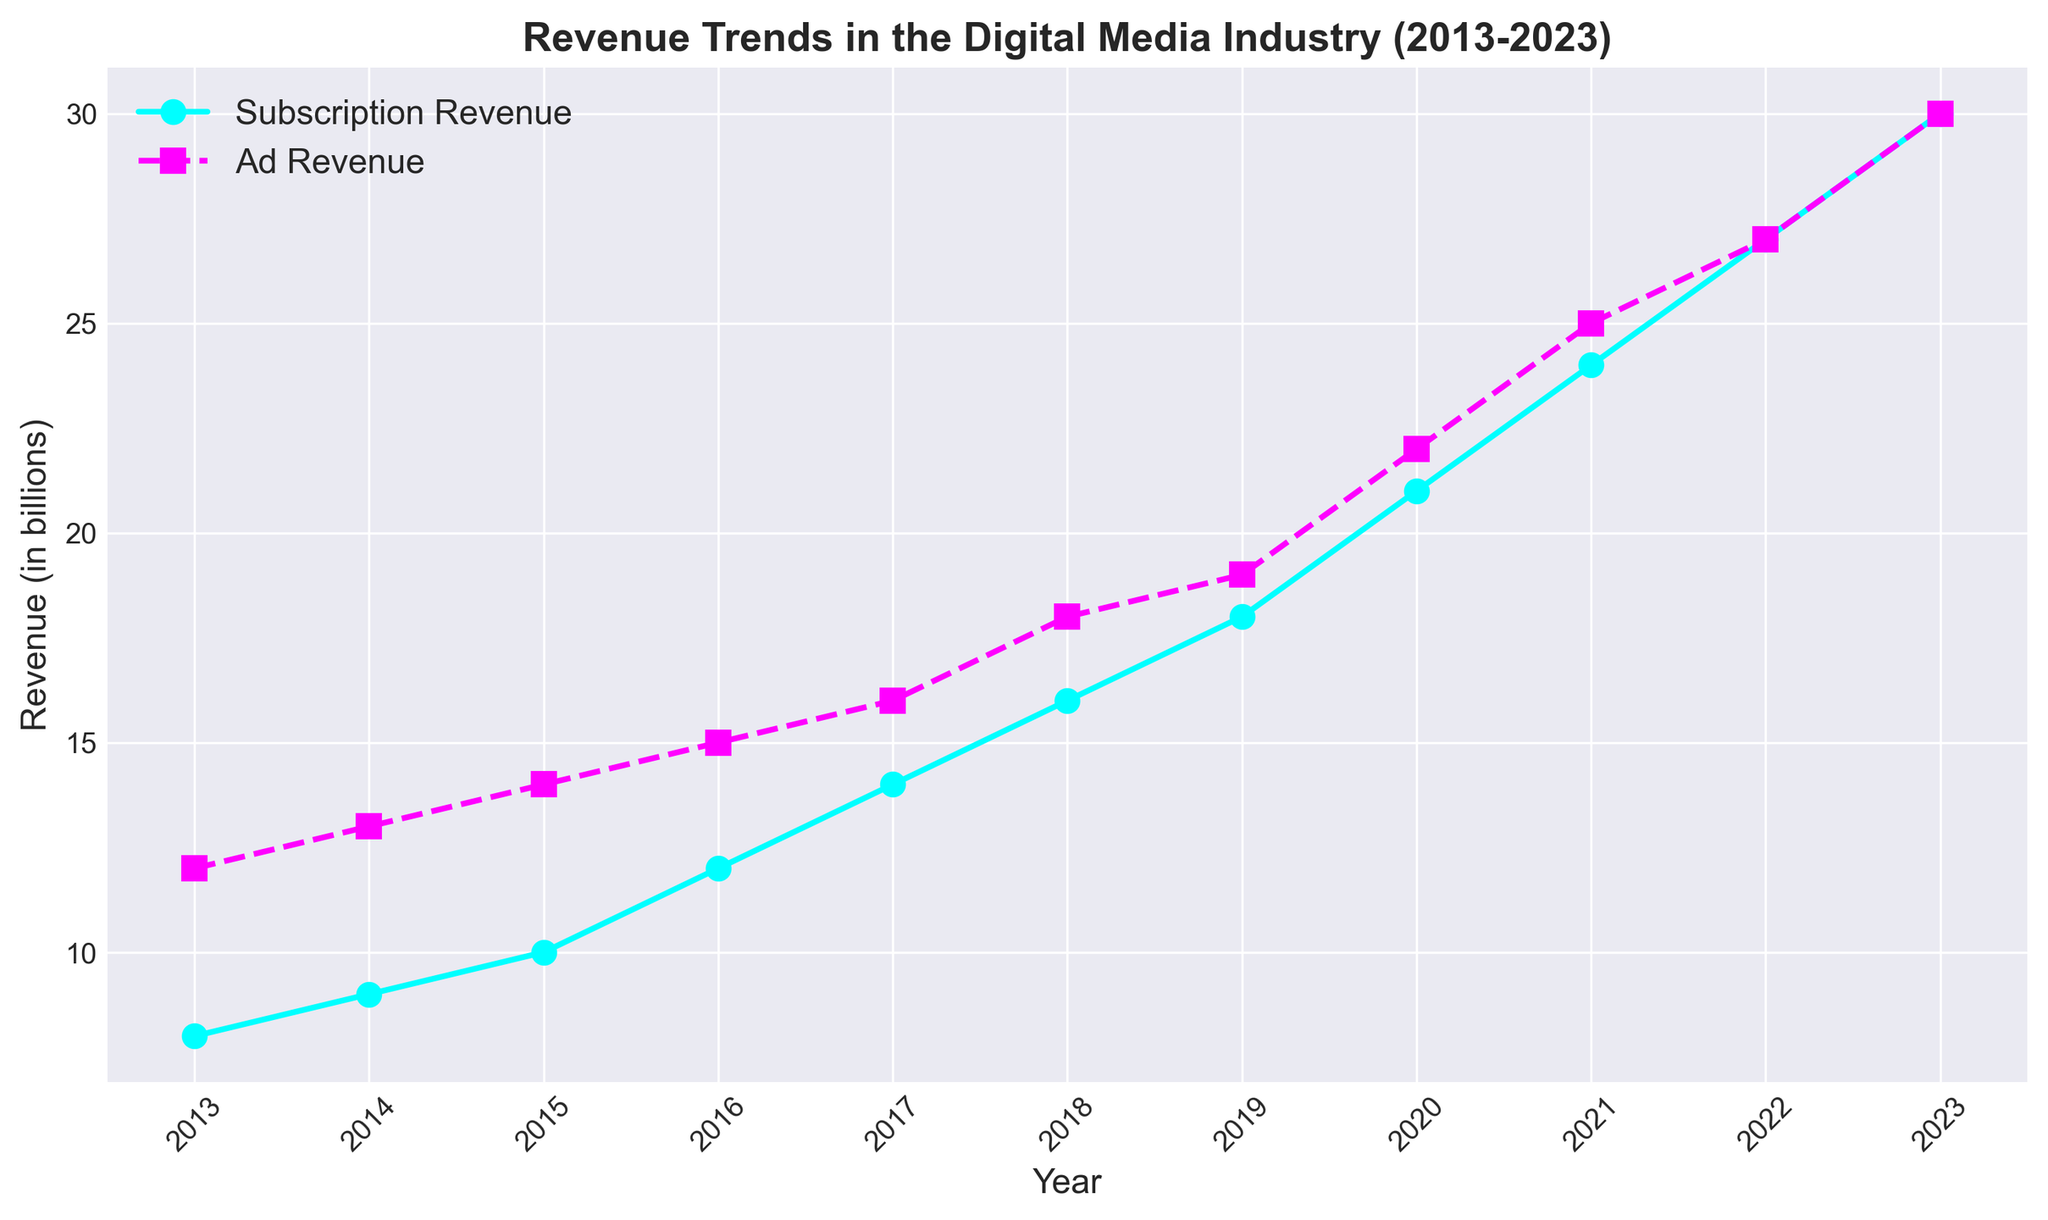What's the trend in subscription revenue from 2013 to 2023? The line representing subscription revenue shows a continuous upward trajectory from 2013 to 2023, starting at 8 billion in 2013 and reaching 30 billion in 2023.
Answer: Upward trend How does the trend in ad revenue compare to the trend in subscription revenue over the decade? Both subscription and ad revenue show an increasing trend. However, subscription revenue increases more steeply, especially from 2020 to 2023, resulting in a higher final value in 2023.
Answer: Subscription revenue increases faster Which year shows an equal revenue for both subscriptions and ads? By looking at the two lines, they intersect at 2022, where both subscription and ad revenue are 27 billion.
Answer: 2022 What is the total combined revenue (subscription + ad) in 2019? Subscription revenue in 2019 is 18 billion and ad revenue is 19 billion. The total combined revenue is 18 + 19 = 37 billion.
Answer: 37 billion In which year is the difference between subscription revenue and ad revenue the highest? By examining the gaps between the two lines, the largest difference appears in 2023, where subscription revenue is 30 billion and ad revenue is 30 billion. The difference is 30 - 30 = 0.
Answer: 2023 Compare the subscription revenue in 2018 with ad revenue in 2014. Which is higher and by how much? Subscription revenue in 2018 is 16 billion, and ad revenue in 2014 is 13 billion. The difference is 16 - 13 = 3 billion. Subscription revenue in 2018 is higher by 3 billion.
Answer: 3 billion What is the average annual ad revenue over the decade? Sum the ad revenues from 2013 to 2023 (12 + 13 + 14 + 15 + 16 + 18 + 19 + 22 + 25 + 27 + 30) = 211 billion. There are 11 years. The average annual ad revenue is 211 / 11 ≈ 19.18 billion.
Answer: 19.18 billion How does the revenue growth between 2019 and 2020 differ for subscriptions and ads? Subscription revenue grows from 18 billion to 21 billion, an increase of 3 billion. Ad revenue grows from 19 billion to 22 billion, an increase of 3 billion. Both revenues increase by 3 billion.
Answer: Both increase by 3 billion What is the percentage increase in subscription revenue from 2017 to 2021? Subscription revenue increases from 14 billion in 2017 to 24 billion in 2021. The increase is 24 - 14 = 10 billion. The percentage increase is (10 / 14) * 100 ≈ 71.43%.
Answer: 71.43% By how much did the ad revenue exceed subscription revenue in 2017? Ad revenue in 2017 is 16 billion, and subscription revenue is 14 billion. The difference is 16 - 14 = 2 billion.
Answer: 2 billion 